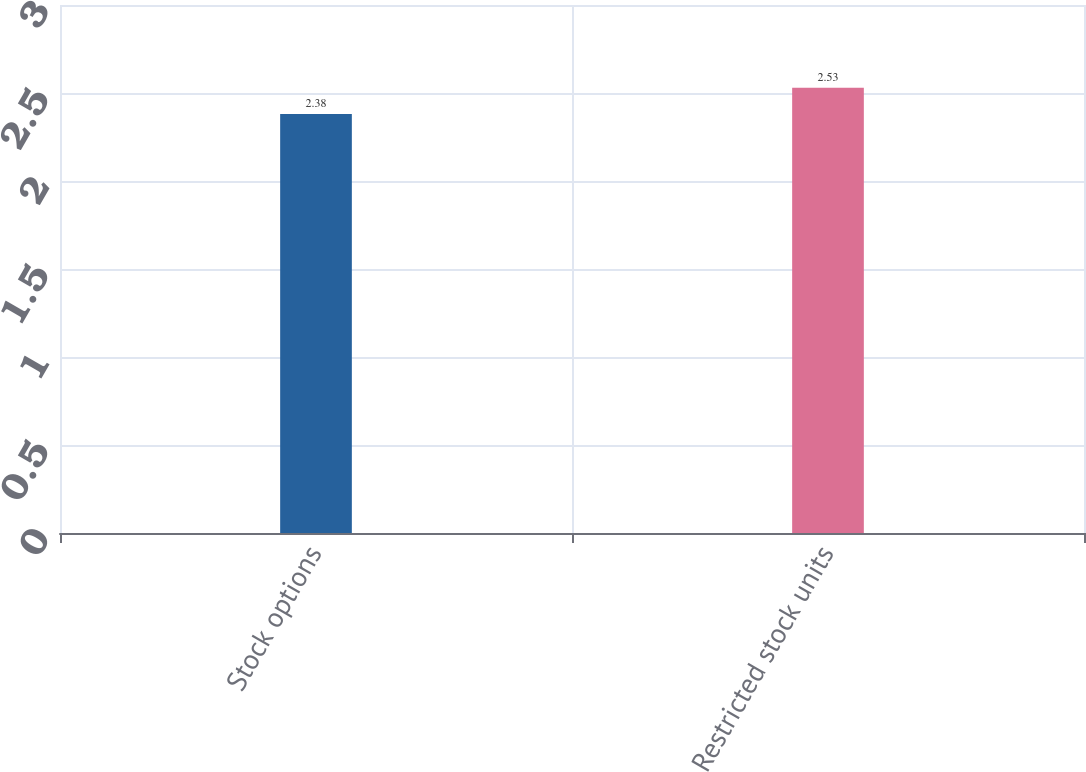Convert chart. <chart><loc_0><loc_0><loc_500><loc_500><bar_chart><fcel>Stock options<fcel>Restricted stock units<nl><fcel>2.38<fcel>2.53<nl></chart> 